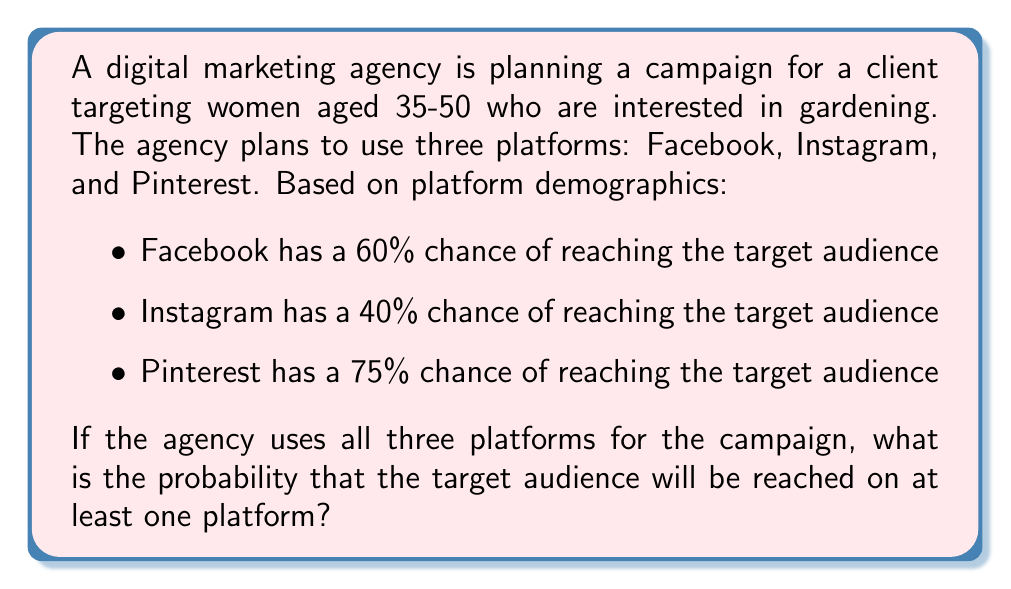Teach me how to tackle this problem. To solve this problem, we'll use the complement rule of probability. Instead of calculating the probability of reaching the audience on at least one platform, we'll calculate the probability of not reaching the audience on any platform and then subtract that from 1.

Let's break it down step-by-step:

1) First, let's calculate the probability of not reaching the audience on each platform:
   - Facebook: $1 - 0.60 = 0.40$
   - Instagram: $1 - 0.40 = 0.60$
   - Pinterest: $1 - 0.75 = 0.25$

2) The probability of not reaching the audience on any platform is the product of these probabilities:

   $P(\text{not reaching on any}) = 0.40 \times 0.60 \times 0.25 = 0.06$

3) Now, we can use the complement rule. The probability of reaching the audience on at least one platform is:

   $P(\text{reaching on at least one}) = 1 - P(\text{not reaching on any})$

4) Plugging in our calculated value:

   $P(\text{reaching on at least one}) = 1 - 0.06 = 0.94$

5) Convert to a percentage:

   $0.94 \times 100\% = 94\%$

Therefore, the probability of reaching the target audience on at least one platform is 94%.
Answer: 94% 